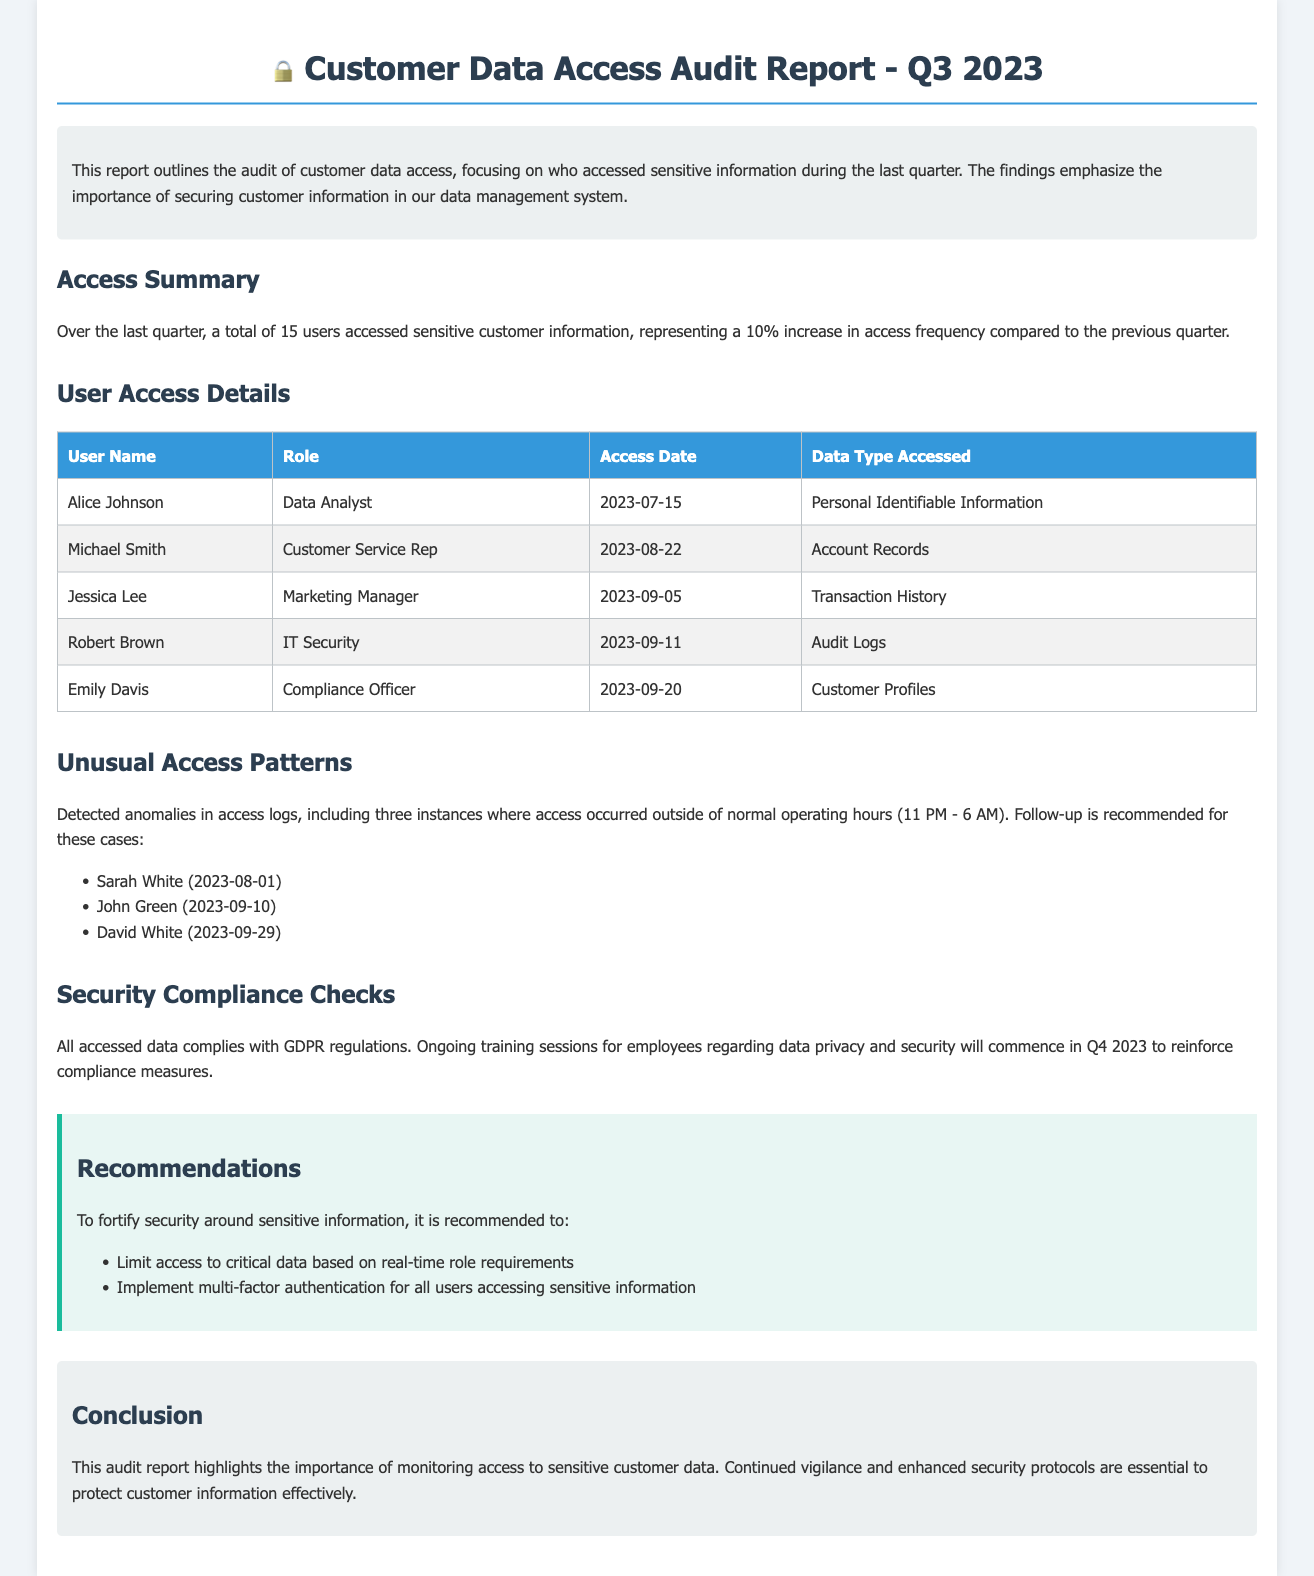What is the title of the report? The title of the report is clearly stated at the top of the document.
Answer: Customer Data Access Audit Report - Q3 2023 How many users accessed sensitive information this quarter? The report provides a specific number for users who accessed sensitive data.
Answer: 15 users What was the date when Jessica Lee accessed data? The report lists access dates for each user, specifically for Jessica Lee.
Answer: 2023-09-05 Which role did Robert Brown have? Each user’s role is provided in the access details.
Answer: IT Security What type of data did Emily Davis access? The document specifies the type of data accessed by each user.
Answer: Customer Profiles How many instances of unusual access were detected? The section about unusual access patterns provides the total count of identified instances.
Answer: 3 instances What is one recommendation made in the report? The recommendations section lists specific ways to improve security.
Answer: Limit access to critical data based on real-time role requirements What regulation compliance was mentioned? The document discusses compliance related to the accessed data.
Answer: GDPR What were the two names mentioned in the unusual access? The section lists individuals involved in unusual access patterns.
Answer: Sarah White and John Green 